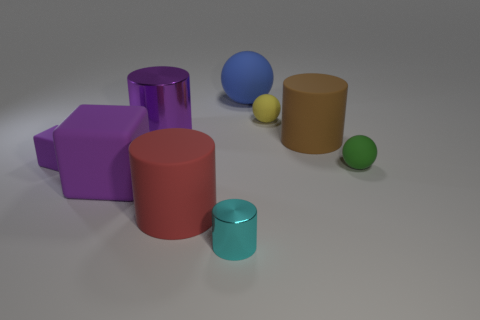How many things are cyan things or big purple rubber things?
Ensure brevity in your answer.  2. Are there any matte cylinders that have the same size as the blue matte object?
Offer a terse response. Yes. The small purple object is what shape?
Keep it short and to the point. Cube. Are there more spheres left of the brown rubber cylinder than purple matte objects left of the big purple rubber block?
Ensure brevity in your answer.  Yes. There is a rubber cylinder on the right side of the yellow object; is it the same color as the rubber cylinder to the left of the big matte ball?
Keep it short and to the point. No. There is a cyan thing that is the same size as the green ball; what shape is it?
Offer a very short reply. Cylinder. Are there any tiny things that have the same shape as the big blue rubber thing?
Offer a terse response. Yes. Do the thing to the left of the big purple cube and the big cylinder to the right of the small metal thing have the same material?
Provide a succinct answer. Yes. The matte object that is the same color as the small block is what shape?
Ensure brevity in your answer.  Cube. What number of tiny yellow things are made of the same material as the large brown object?
Provide a succinct answer. 1. 